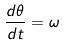<formula> <loc_0><loc_0><loc_500><loc_500>\frac { d \theta } { d t } = \omega</formula> 